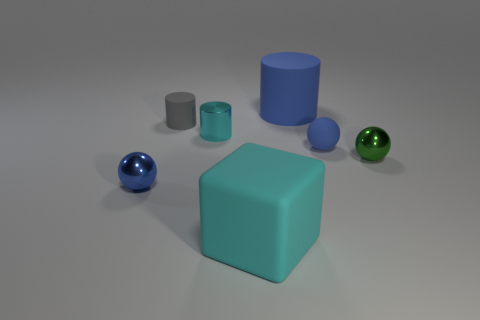Subtract all blue balls. How many were subtracted if there are1blue balls left? 1 Add 1 blue rubber things. How many objects exist? 8 Subtract all cubes. How many objects are left? 6 Add 3 big blue rubber things. How many big blue rubber things exist? 4 Subtract 0 red balls. How many objects are left? 7 Subtract all small blue rubber balls. Subtract all tiny blue spheres. How many objects are left? 4 Add 6 blue metal things. How many blue metal things are left? 7 